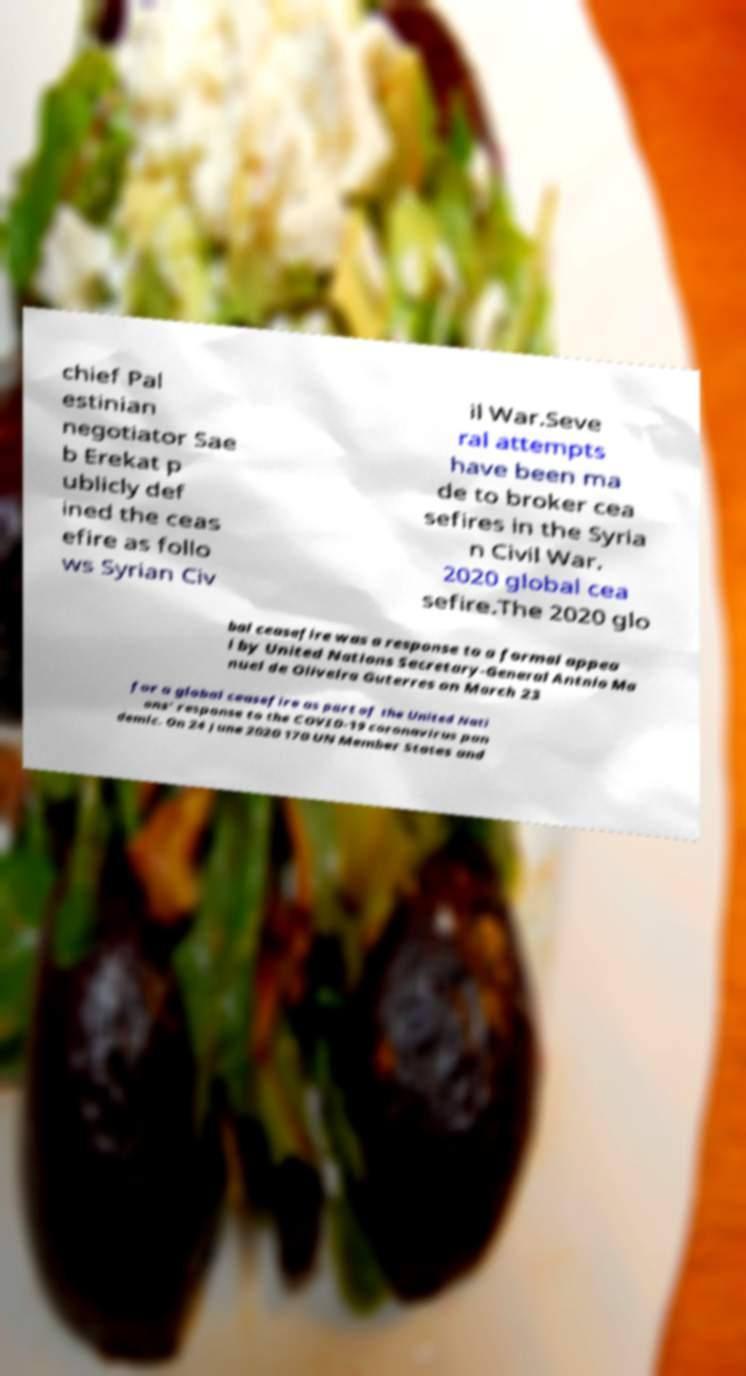Please identify and transcribe the text found in this image. chief Pal estinian negotiator Sae b Erekat p ublicly def ined the ceas efire as follo ws Syrian Civ il War.Seve ral attempts have been ma de to broker cea sefires in the Syria n Civil War. 2020 global cea sefire.The 2020 glo bal ceasefire was a response to a formal appea l by United Nations Secretary-General Antnio Ma nuel de Oliveira Guterres on March 23 for a global ceasefire as part of the United Nati ons' response to the COVID-19 coronavirus pan demic. On 24 June 2020 170 UN Member States and 